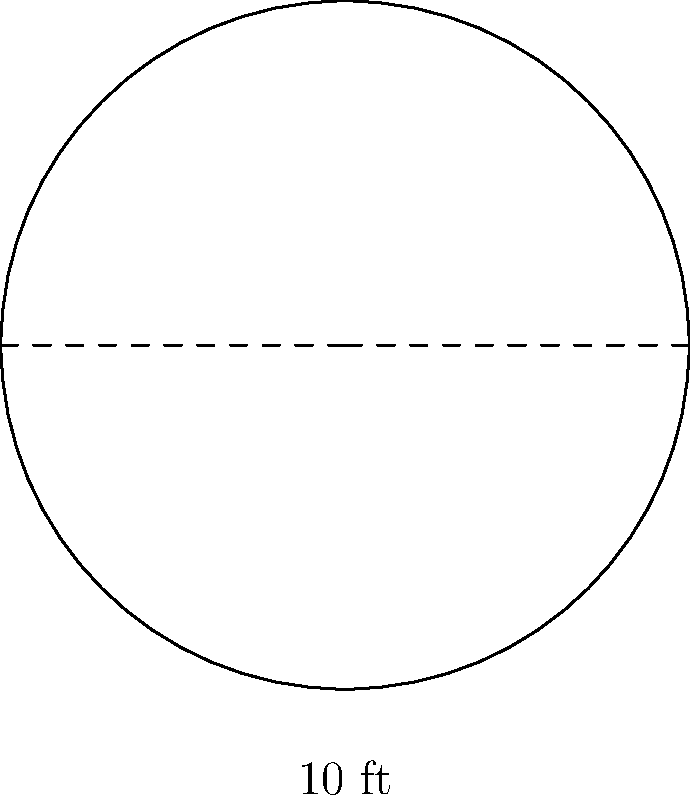In the historical records of your family's garden design, you find a blueprint for a circular fountain. The diagram shows that the fountain has a diameter of 10 feet. What is the area of this circular fountain? To find the area of the circular fountain, we'll follow these steps:

1) First, recall the formula for the area of a circle:
   $$A = \pi r^2$$
   where $A$ is the area and $r$ is the radius.

2) We're given the diameter, which is 10 feet. The radius is half of the diameter:
   $$r = \frac{10}{2} = 5\text{ feet}$$

3) Now we can substitute this into our area formula:
   $$A = \pi (5)^2$$

4) Simplify:
   $$A = 25\pi\text{ square feet}$$

5) If we need to give a decimal approximation, we can use $\pi \approx 3.14159$:
   $$A \approx 25 \times 3.14159 \approx 78.54\text{ square feet}$$

Therefore, the area of the circular fountain is $25\pi$ or approximately 78.54 square feet.
Answer: $25\pi\text{ sq ft}$ (or $\approx 78.54\text{ sq ft}$) 